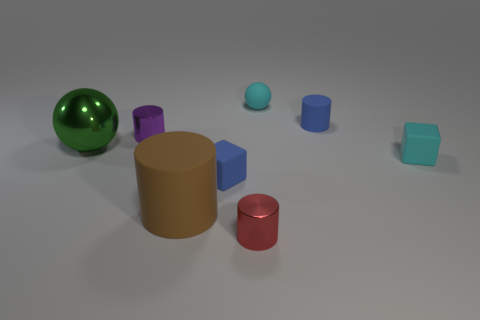There is a small rubber block on the right side of the tiny blue rubber block; is it the same color as the tiny ball?
Offer a very short reply. Yes. There is a big thing that is the same material as the tiny red cylinder; what is its shape?
Offer a very short reply. Sphere. What color is the metallic object that is to the right of the green metal thing and behind the small cyan rubber cube?
Make the answer very short. Purple. Does the object behind the small matte cylinder have the same material as the small red cylinder?
Offer a very short reply. No. Are there fewer cylinders to the left of the large green metal object than gray metallic spheres?
Provide a short and direct response. No. Is there a brown object made of the same material as the blue block?
Give a very brief answer. Yes. There is a blue rubber block; does it have the same size as the rubber cylinder right of the large matte cylinder?
Provide a short and direct response. Yes. Is there a thing that has the same color as the small sphere?
Make the answer very short. Yes. Do the purple cylinder and the green object have the same material?
Your response must be concise. Yes. There is a purple shiny thing; how many objects are to the right of it?
Your answer should be compact. 6. 